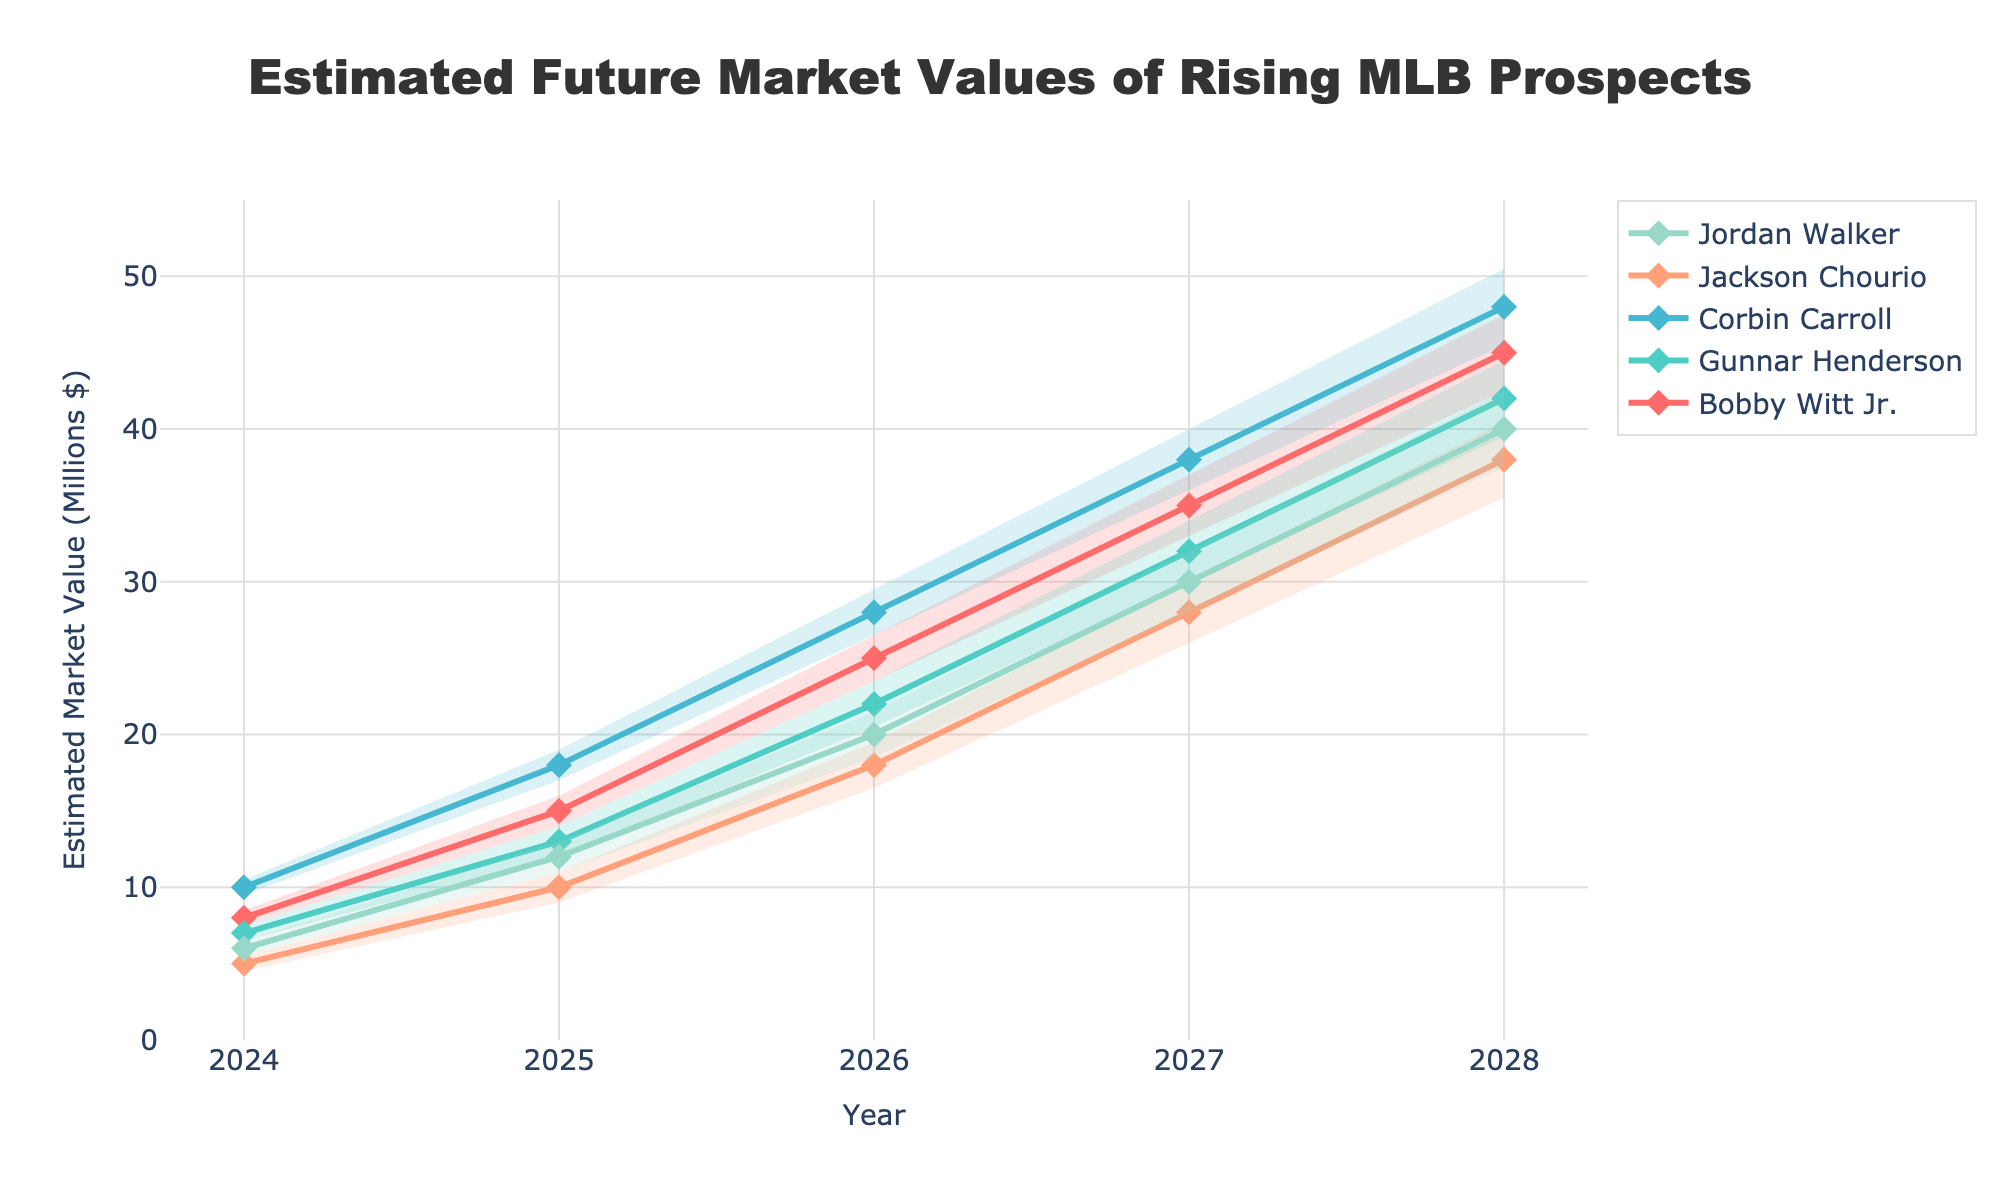How many years are displayed on the x-axis? The x-axis lists the years presented in the figure, from 2024 to 2028. You can count them to determine the total number of years.
Answer: 5 What is the estimated market value of Corbin Carroll in 2026? You need to locate Corbin Carroll's line and find the data point corresponding to the year 2026.
Answer: 28 million dollars Which player has the highest estimated market value in 2028? Look at the endpoint values of each player's line on the plot for the year 2028 and identify the highest one.
Answer: Bobby Witt Jr What is the difference in the estimated market value between Jordan Walker and Jackson Chourio in 2027? Find the 2027 values for Jordan Walker and Jackson Chourio, then subtract Jackson Chourio's value from Jordan Walker's value. Jordan Walker is at 30 million dollars and Jackson Chourio is at 28 million dollars, so 30 - 28 = 2.
Answer: 2 million dollars How does the market value trend for Gunnar Henderson compare to Bobby Witt Jr.? Both players' trends show a clear increase from 2024 to 2028. You can compare their slopes and values. Gunnar Henderson's values are consistently lower and increases at a similar rate to Bobby Witt Jr.'s.
Answer: Gunnar Henderson's values are consistently lower but follow a similar increasing trend On average, how much does the estimated market value of Jordan Walker increase per year from 2024 to 2028? Calculate the difference between the 2028 value and 2024 value for Jordan Walker, then divide by the number of years. (40 - 6) / (2028 - 2024) = 34 / 4 = 8.5.
Answer: 8.5 million dollars per year Which player has the widest prediction interval in 2025, and how wide is it? Determine the upper and lower bounds for each player's interval in 2025 and find the player with the greatest difference.
Answer: Bobby Witt Jr., 15 - (15 - 1.0) = 16 What player shows the most significant growth trend in estimated market value? Check each player's growth from 2024 to 2028 and determine the steepest increase in values. Bobby Witt Jr.'s values rise from 8 to 45, which is the most significant.
Answer: Bobby Witt Jr In which year is the estimated market value of Gunnar Henderson equal to the current market value of Bobby Witt Jr.? Follow Gunnar Henderson's trajectory to find a value equal to Bobby Witt Jr.'s initial 2024 value of 8. Gunnar Henderson does not reach 8 million dollars until 2024.
Answer: 2024 Which player consistently has the lowest estimated market values from 2024 to 2028? Compare the trends and values for each year of all players to see which player stays consistently at the bottom. Jackson Chourio has the lowest initial value and remains lower relative to others.
Answer: Jackson Chourio 